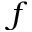<formula> <loc_0><loc_0><loc_500><loc_500>f</formula> 